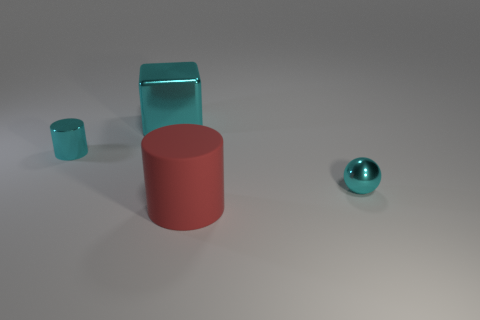Add 2 cyan spheres. How many objects exist? 6 Subtract all balls. How many objects are left? 3 Subtract 0 brown balls. How many objects are left? 4 Subtract all matte things. Subtract all metallic cylinders. How many objects are left? 2 Add 1 cyan shiny cylinders. How many cyan shiny cylinders are left? 2 Add 4 brown cubes. How many brown cubes exist? 4 